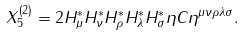<formula> <loc_0><loc_0><loc_500><loc_500>X _ { 5 } ^ { \left ( 2 \right ) } = 2 H _ { \mu } ^ { * } H _ { \nu } ^ { * } H _ { \rho } ^ { * } H _ { \lambda } ^ { * } H _ { \sigma } ^ { * } \eta C \eta ^ { \mu \nu \rho \lambda \sigma } .</formula> 